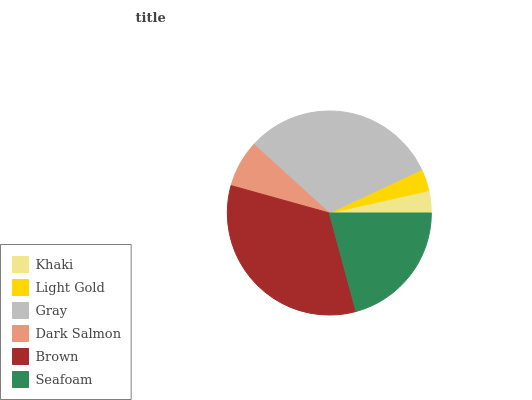Is Light Gold the minimum?
Answer yes or no. Yes. Is Brown the maximum?
Answer yes or no. Yes. Is Gray the minimum?
Answer yes or no. No. Is Gray the maximum?
Answer yes or no. No. Is Gray greater than Light Gold?
Answer yes or no. Yes. Is Light Gold less than Gray?
Answer yes or no. Yes. Is Light Gold greater than Gray?
Answer yes or no. No. Is Gray less than Light Gold?
Answer yes or no. No. Is Seafoam the high median?
Answer yes or no. Yes. Is Dark Salmon the low median?
Answer yes or no. Yes. Is Brown the high median?
Answer yes or no. No. Is Khaki the low median?
Answer yes or no. No. 